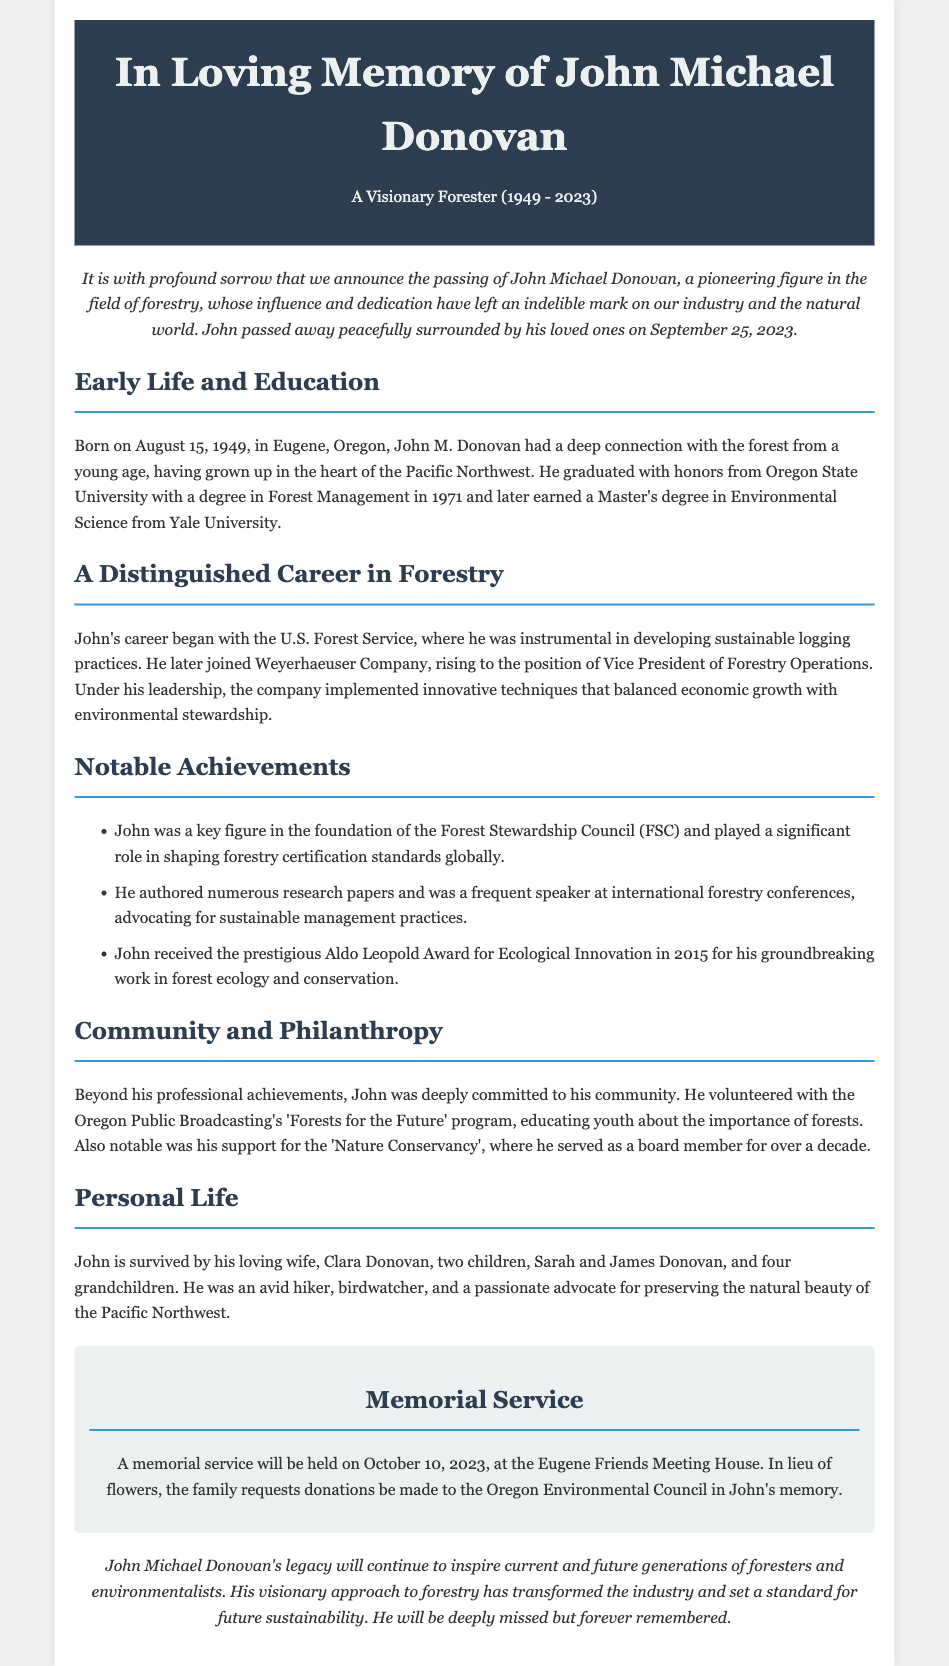What was John Michael Donovan's birth date? The document states that John Michael Donovan was born on August 15, 1949.
Answer: August 15, 1949 What degree did John earn from Oregon State University? The document specifies that he graduated with a degree in Forest Management from Oregon State University.
Answer: Forest Management Who was John Michael Donovan's wife? The document mentions that he is survived by his loving wife, Clara Donovan.
Answer: Clara Donovan What award did John receive in 2015? The document notes that John received the Aldo Leopold Award for Ecological Innovation in 2015.
Answer: Aldo Leopold Award What organization did John contribute to as a board member? The document states that John served as a board member for the Nature Conservancy for over a decade.
Answer: Nature Conservancy What significant council did John help to found? The document indicates that John was a key figure in the foundation of the Forest Stewardship Council (FSC).
Answer: Forest Stewardship Council What kind of practices did John advocate for? The document mentions that John advocated for sustainable management practices.
Answer: Sustainable management practices When is the memorial service scheduled? The document specifies that the memorial service will be held on October 10, 2023.
Answer: October 10, 2023 What was one of John's personal hobbies? The document mentions that John was an avid hiker.
Answer: Hiker 